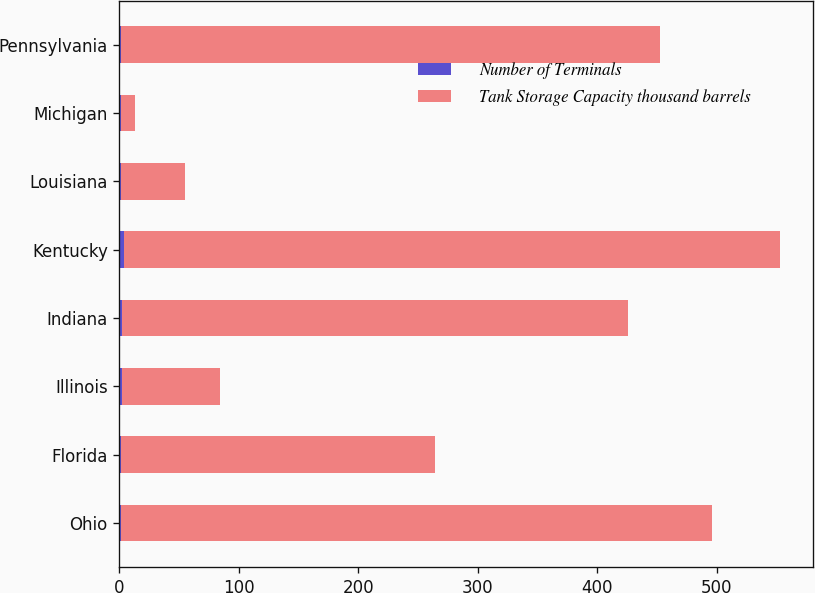<chart> <loc_0><loc_0><loc_500><loc_500><stacked_bar_chart><ecel><fcel>Ohio<fcel>Florida<fcel>Illinois<fcel>Indiana<fcel>Kentucky<fcel>Louisiana<fcel>Michigan<fcel>Pennsylvania<nl><fcel>Number of Terminals<fcel>1<fcel>1<fcel>2<fcel>2<fcel>4<fcel>1<fcel>1<fcel>1<nl><fcel>Tank Storage Capacity thousand barrels<fcel>495<fcel>263<fcel>82<fcel>424<fcel>549<fcel>54<fcel>12<fcel>452<nl></chart> 